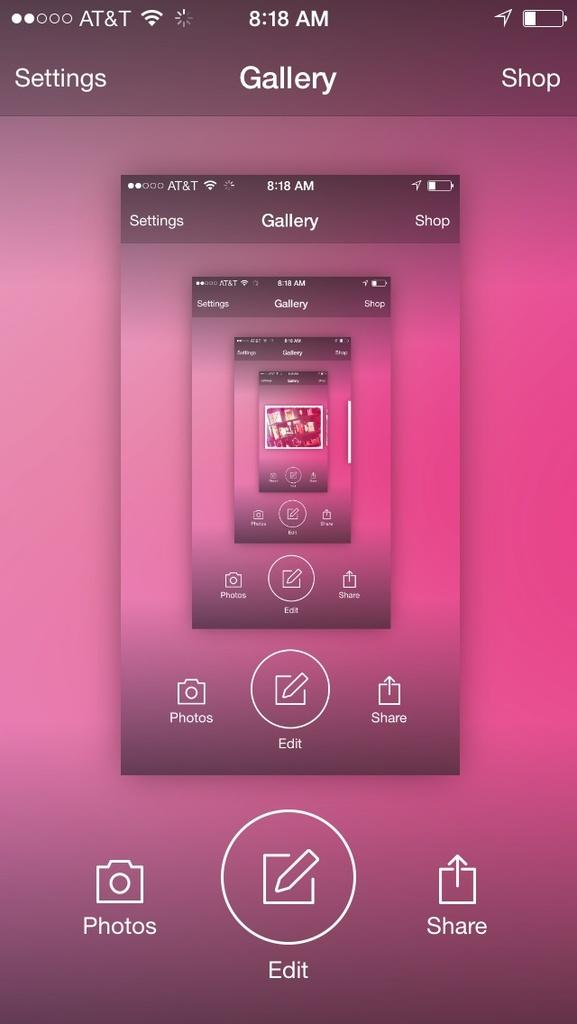<image>
Summarize the visual content of the image. an AT&T cell phone in Gallery app editing a photo 